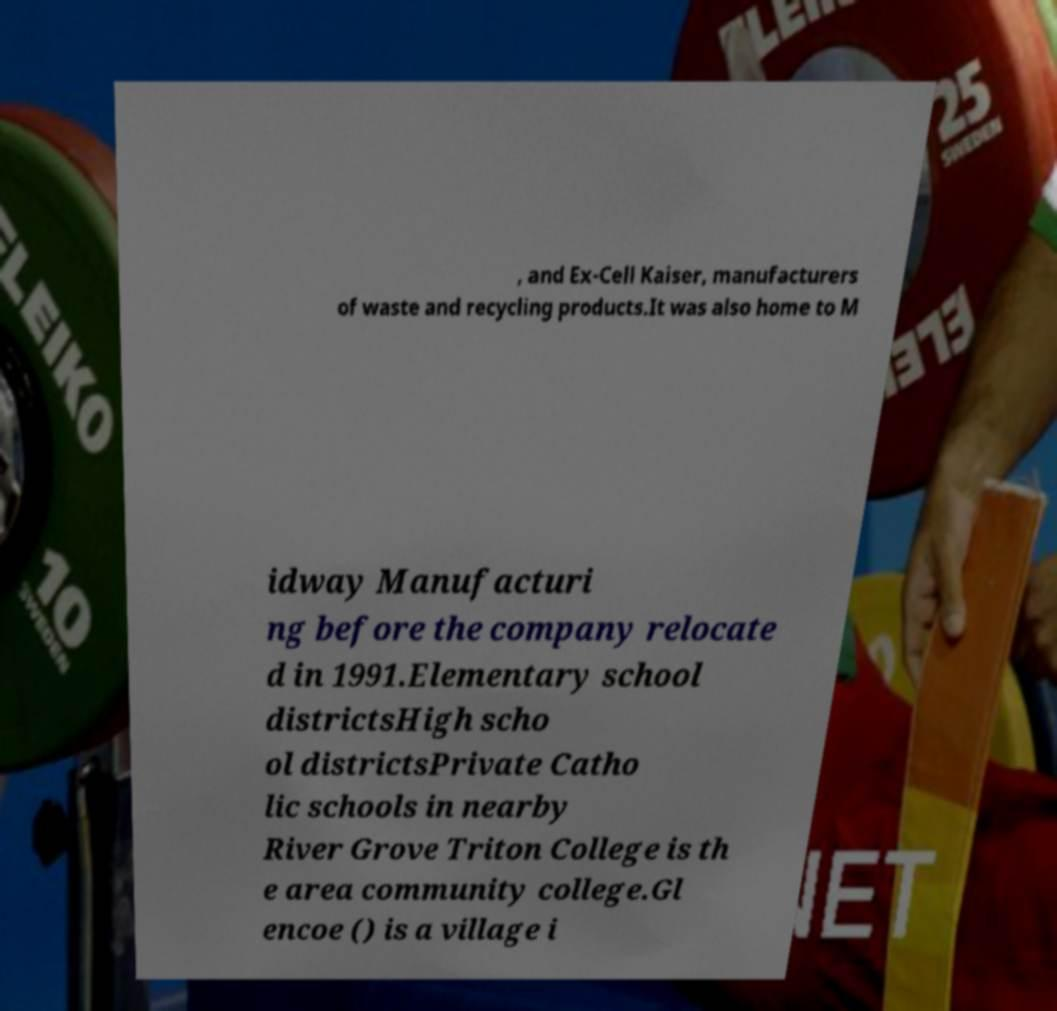Could you assist in decoding the text presented in this image and type it out clearly? , and Ex-Cell Kaiser, manufacturers of waste and recycling products.It was also home to M idway Manufacturi ng before the company relocate d in 1991.Elementary school districtsHigh scho ol districtsPrivate Catho lic schools in nearby River Grove Triton College is th e area community college.Gl encoe () is a village i 